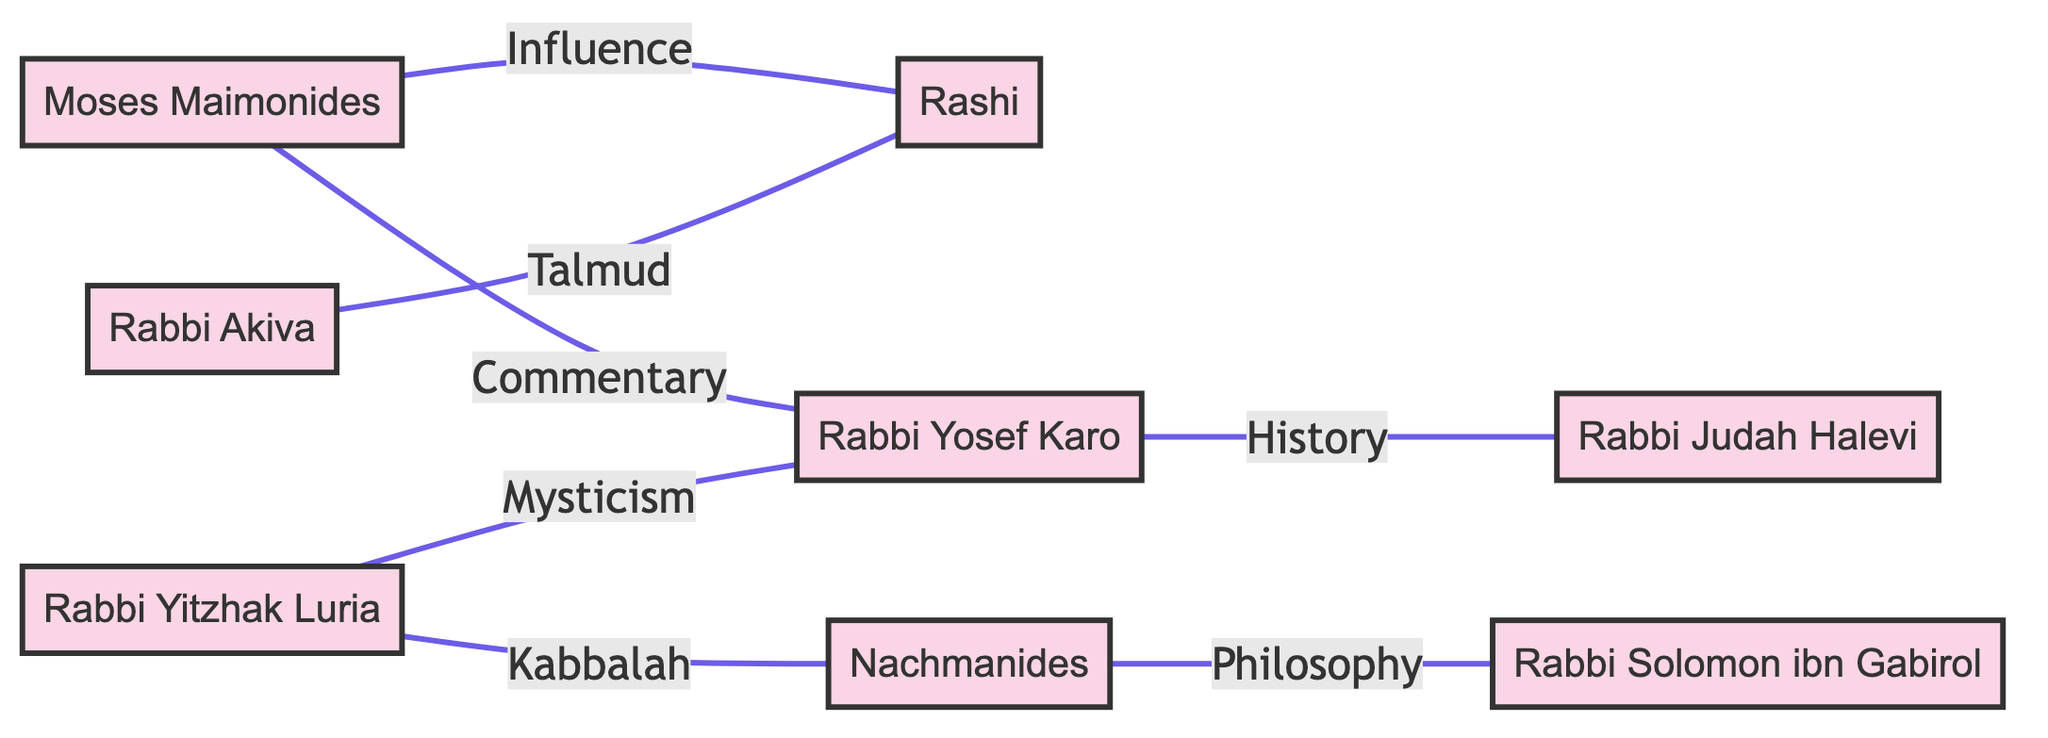What is the total number of scholars represented in the diagram? The diagram lists eight unique scholars as nodes: Moses Maimonides, Rashi, Rabbi Akiva, Nachmanides, Rabbi Yosef Karo, Rabbi Solomon ibn Gabirol, Rabbi Judah Halevi, and Rabbi Yitzhak Luria. Counting these gives a total of 8 scholars.
Answer: 8 Which scholar is connected to both Rashi and Rabbi Yosef Karo? After examining the connections, Moses Maimonides has edges leading to both Rashi (labeled "Influence") and Rabbi Yosef Karo (labeled "Commentary"). Thus, he is the scholar connected to both.
Answer: Moses Maimonides What type of relationship exists between Nachmanides and Rabbi Solomon ibn Gabirol? The diagram shows an edge between Nachmanides and Rabbi Solomon ibn Gabirol labeled "Philosophy," indicating a philosophical relationship or influence between them.
Answer: Philosophy How many edges connect Rabbi Yitzhak Luria to other scholars? By inspecting the edges, Rabbi Yitzhak Luria has two connections: one to Nachmanides (labeled "Kabbalah") and another to Rabbi Yosef Karo (labeled "Mysticism"), resulting in a total of 2 edges.
Answer: 2 Which scholar focuses on Commentary related to Moses Maimonides? The edge from Moses Maimonides to Rabbi Yosef Karo is specifically labeled "Commentary," indicating that Rabbi Yosef Karo focuses on commentary related to Moses Maimonides.
Answer: Rabbi Yosef Karo What is the common theme connecting Rabbi Yitzhak Luria to Rabbi Yosef Karo? The diagram shows an edge from Rabbi Yitzhak Luria to Rabbi Yosef Karo labeled "Mysticism," indicating that the common theme connecting them is related to mystical teachings or interpretations.
Answer: Mysticism Who is the earliest cited scholar contributing to Talmudic writings? The diagram presents Rabbi Akiva connected to Rashi with the label "Talmud." This connection suggests that Rabbi Akiva is the earliest cited scholar in this context, contributing to Talmudic writings.
Answer: Rabbi Akiva What single word represents the influence of Moses Maimonides on Rashi? The edge connecting Moses Maimonides to Rashi is labeled "Influence," directly indicating his influence over Rashi.
Answer: Influence 